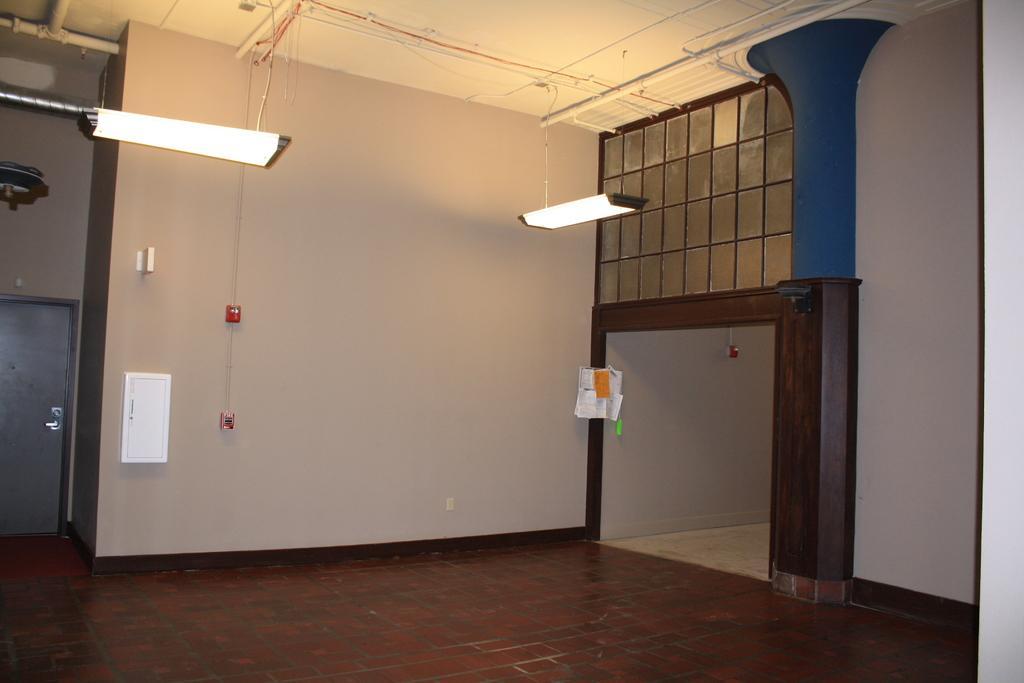Could you give a brief overview of what you see in this image? This image is clicked inside the room. On the right, we can see a door. At the top, there are lights hanged to the roof. In the front, there is a wall. On the left, there is a door. At the bottom, there is a roof. 